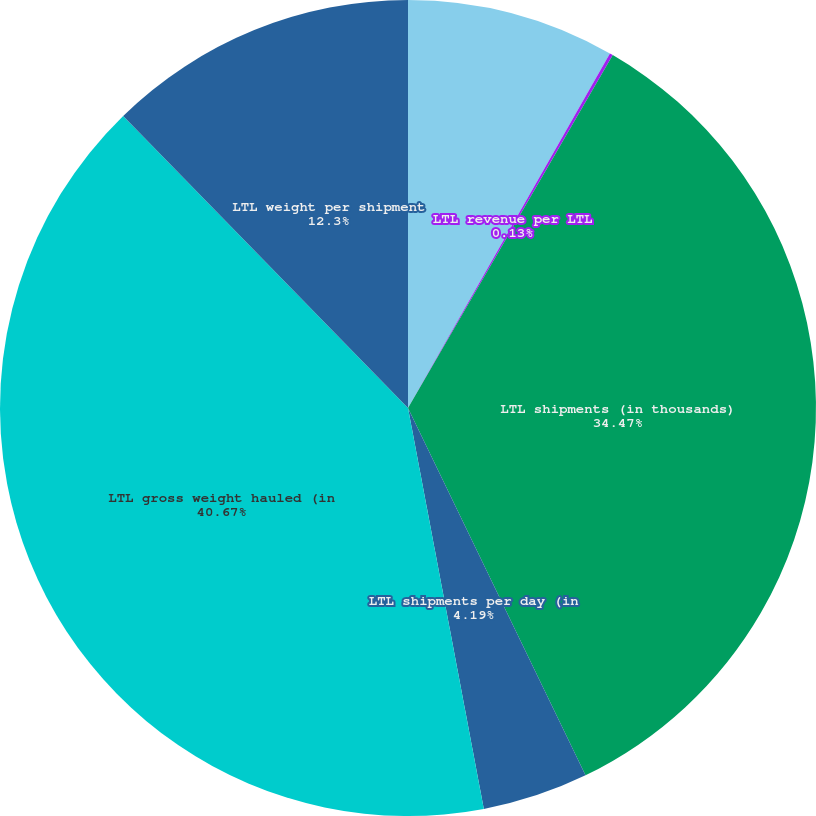<chart> <loc_0><loc_0><loc_500><loc_500><pie_chart><fcel>LTL revenue (in millions)<fcel>LTL revenue per LTL<fcel>LTL shipments (in thousands)<fcel>LTL shipments per day (in<fcel>LTL gross weight hauled (in<fcel>LTL weight per shipment<nl><fcel>8.24%<fcel>0.13%<fcel>34.47%<fcel>4.19%<fcel>40.68%<fcel>12.3%<nl></chart> 